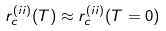<formula> <loc_0><loc_0><loc_500><loc_500>r _ { c } ^ { ( i i ) } ( T ) \approx r _ { c } ^ { ( i i ) } { ( T = 0 ) }</formula> 